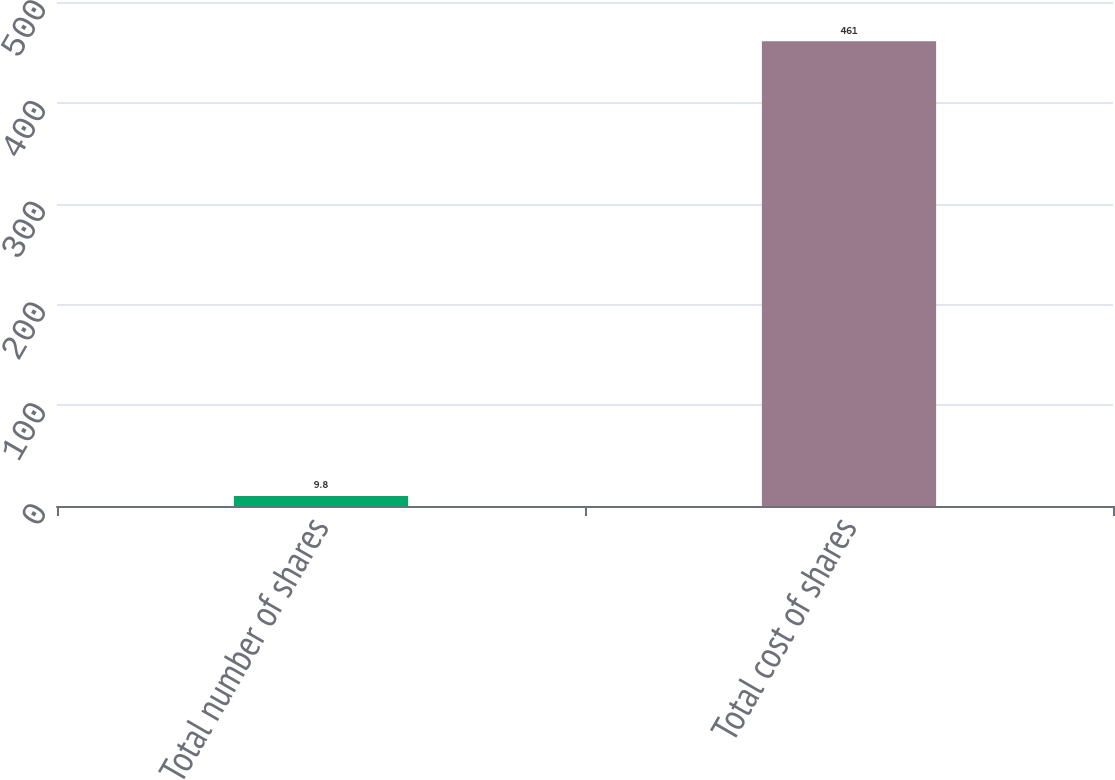<chart> <loc_0><loc_0><loc_500><loc_500><bar_chart><fcel>Total number of shares<fcel>Total cost of shares<nl><fcel>9.8<fcel>461<nl></chart> 